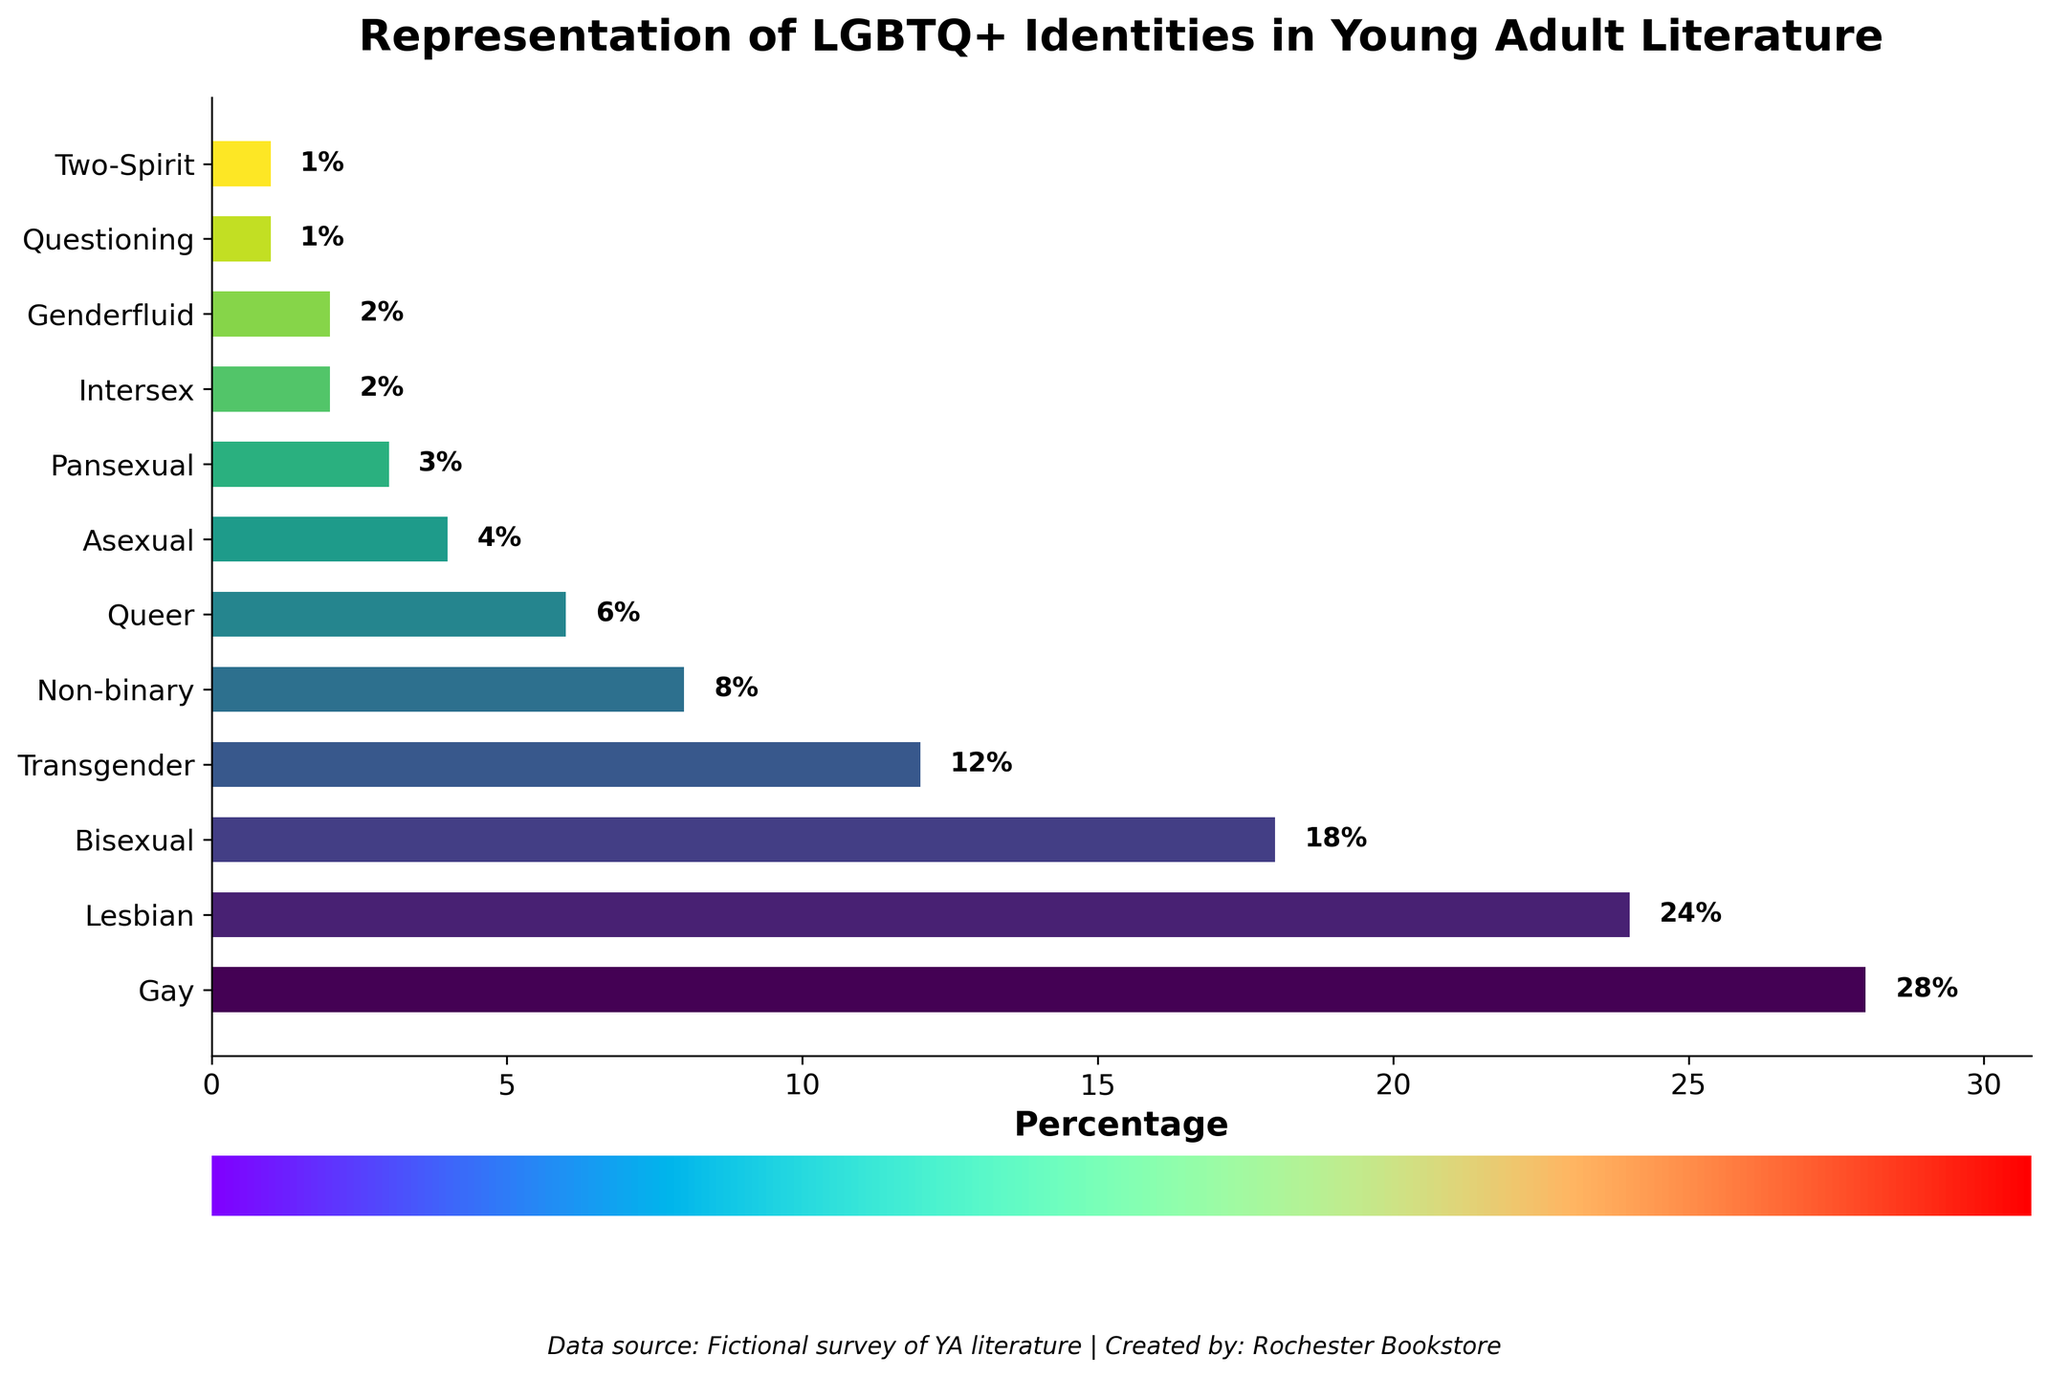What percentage of young adult literature represents Gay identities? Look at the bar labeled "Gay" and read the percentage value next to it, which is 28%.
Answer: 28% How many identities are represented by less than 5% of the total? Count the bars with values less than 5%. These are Asexual (4%), Pansexual (3%), Intersex (2%), Genderfluid (2%), Questioning (1%), and Two-Spirit (1%). There are 6 such identities.
Answer: 6 Which identity has the third highest representation in young adult literature? Rank the bars by their heights/percentages. Gay (28%), Lesbian (24%), and Bisexual (18%). The third highest is Bisexual.
Answer: Bisexual What is the combined percentage of Non-binary, Queer, and Asexual identities? Add the percentages of Non-binary (8%), Queer (6%), and Asexual (4%). 8% + 6% + 4% = 18%
Answer: 18% Is the representation of Lesbian identities greater than or equal to that of Bisexual and Non-binary identities combined? Compare the sum of Bisexual (18%) and Non-binary (8%) which is 26%, with Lesbian (24%). 24% is not greater than or equal to 26%.
Answer: No What is the median representation percentage among all the listed identities? Sort the percentages: 1%, 1%, 2%, 2%, 3%, 4%, 6%, 8%, 12%, 18%, 24%, 28%. The median is the average of the 6th and 7th values: (4% + 6%)/2 = 5%.
Answer: 5% Which identities are represented by exactly 2% of the total? Look for bars labeled with 2%. They are Intersex and Genderfluid.
Answer: Intersex, Genderfluid Which LGBTQ+ identity has the lowest representation in young adult literature? Find the identity with the shortest bar, which is the Questioning and Two-Spirit bars, both at 1%.
Answer: Questioning, Two-Spirit Are there more identities represented by 12% or more than those represented by 5% or less? Identify those 12% or more: Gay (28%), Lesbian (24%), Bisexual (18%), Transgender (12%) = 4. For 5% or less: Asexual (4%), Pansexual (3%), Intersex (2%), Genderfluid (2%), Questioning (1%), Two-Spirit (1%) = 6. There are more identities represented by 5% or less.
Answer: No 